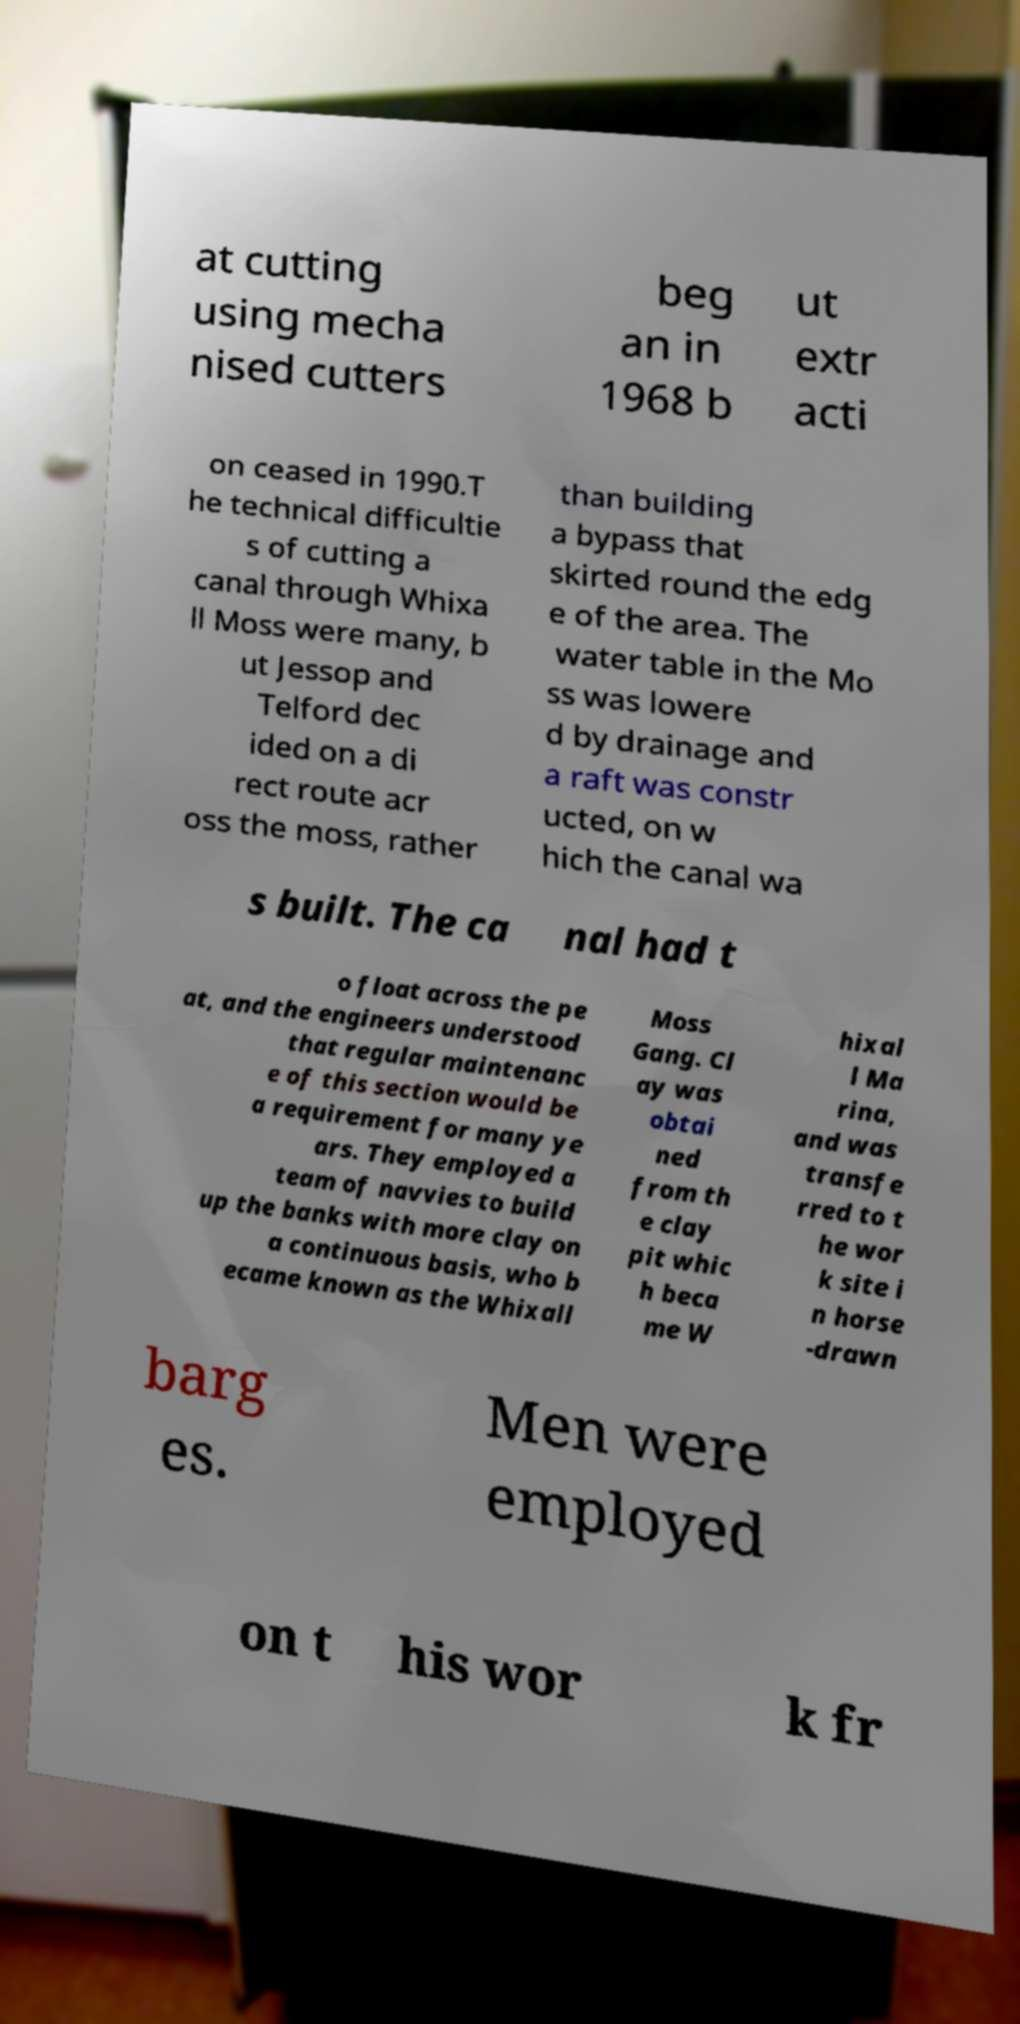There's text embedded in this image that I need extracted. Can you transcribe it verbatim? at cutting using mecha nised cutters beg an in 1968 b ut extr acti on ceased in 1990.T he technical difficultie s of cutting a canal through Whixa ll Moss were many, b ut Jessop and Telford dec ided on a di rect route acr oss the moss, rather than building a bypass that skirted round the edg e of the area. The water table in the Mo ss was lowere d by drainage and a raft was constr ucted, on w hich the canal wa s built. The ca nal had t o float across the pe at, and the engineers understood that regular maintenanc e of this section would be a requirement for many ye ars. They employed a team of navvies to build up the banks with more clay on a continuous basis, who b ecame known as the Whixall Moss Gang. Cl ay was obtai ned from th e clay pit whic h beca me W hixal l Ma rina, and was transfe rred to t he wor k site i n horse -drawn barg es. Men were employed on t his wor k fr 